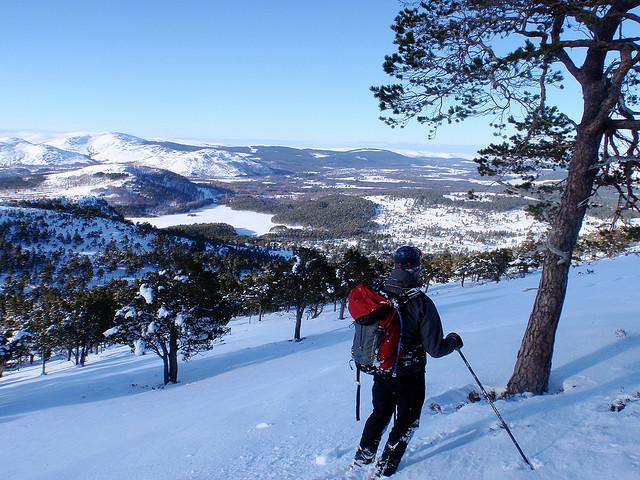What is covering the trees?
Give a very brief answer. Snow. What is in the background?
Quick response, please. Mountains. What is the season?
Concise answer only. Winter. 